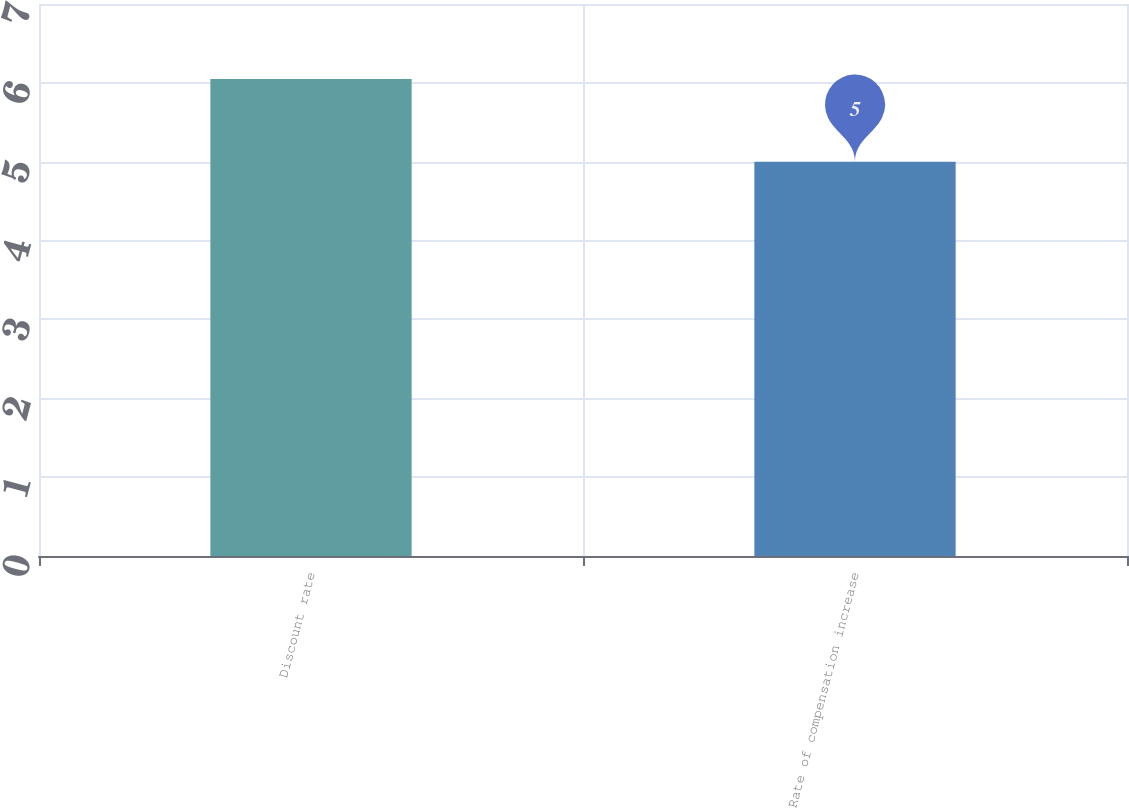Convert chart. <chart><loc_0><loc_0><loc_500><loc_500><bar_chart><fcel>Discount rate<fcel>Rate of compensation increase<nl><fcel>6.05<fcel>5<nl></chart> 